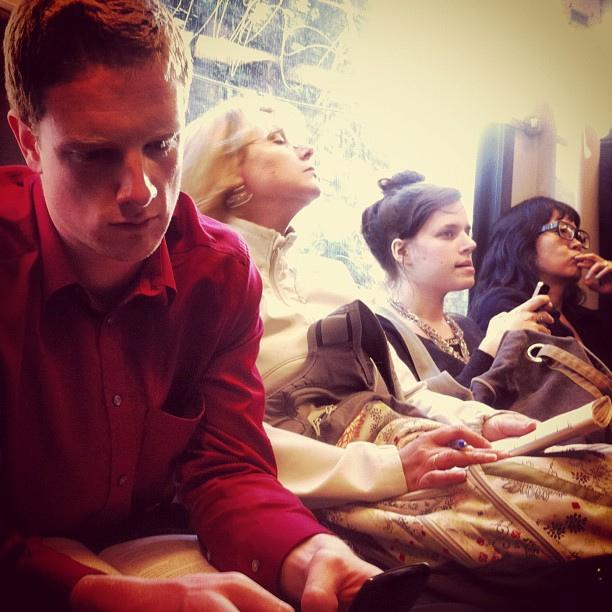The expression on the people's faces reveal that the bus is what?

Choices:
A) fun
B) unpleasant
C) pleasant
D) scary unpleasant 